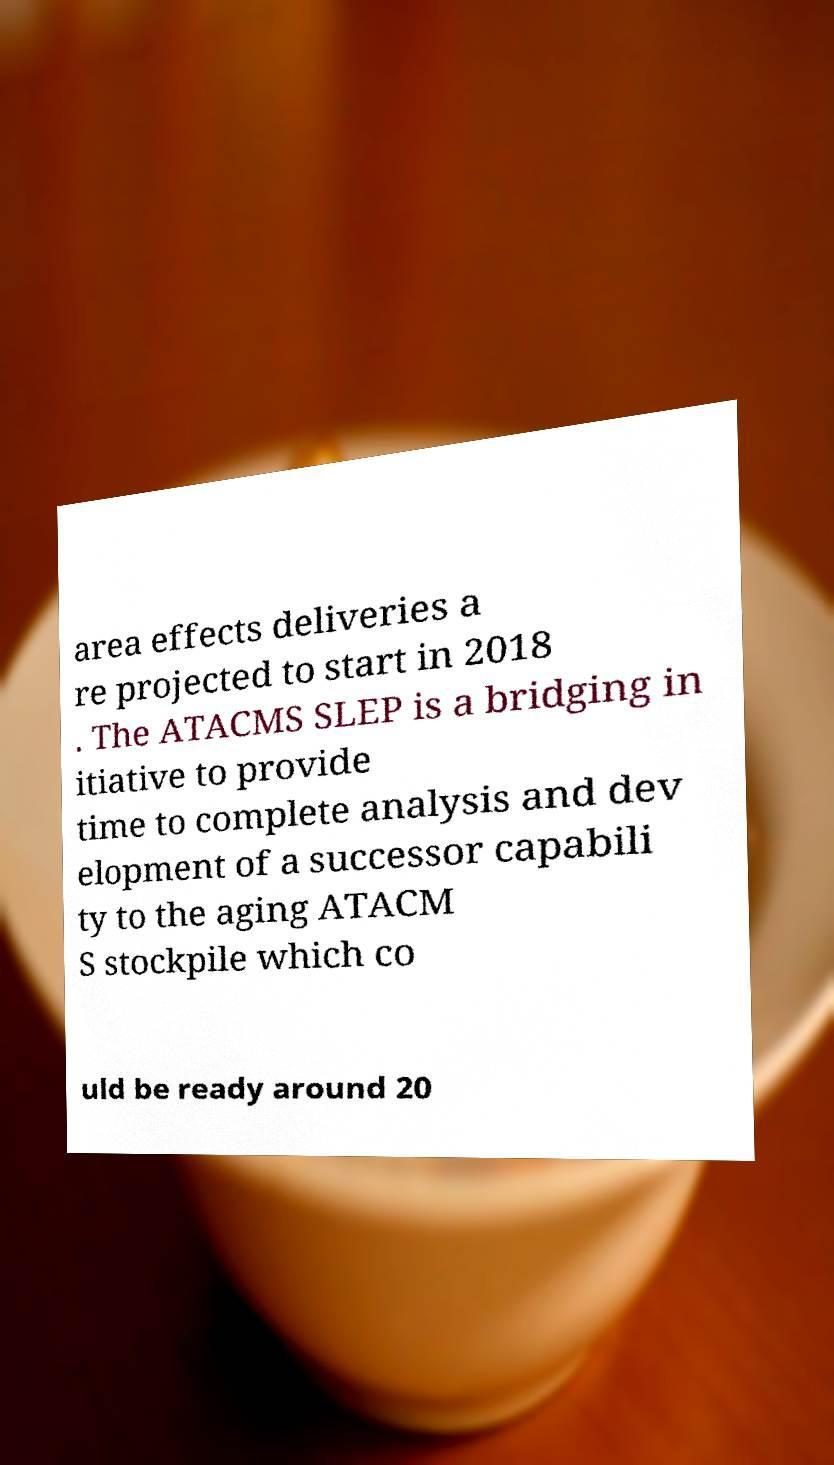Can you read and provide the text displayed in the image?This photo seems to have some interesting text. Can you extract and type it out for me? area effects deliveries a re projected to start in 2018 . The ATACMS SLEP is a bridging in itiative to provide time to complete analysis and dev elopment of a successor capabili ty to the aging ATACM S stockpile which co uld be ready around 20 